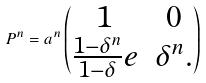<formula> <loc_0><loc_0><loc_500><loc_500>P ^ { n } = a ^ { n } \begin{pmatrix} 1 & 0 \\ \frac { 1 - \delta ^ { n } } { 1 - \delta } e & \delta ^ { n } . \end{pmatrix}</formula> 